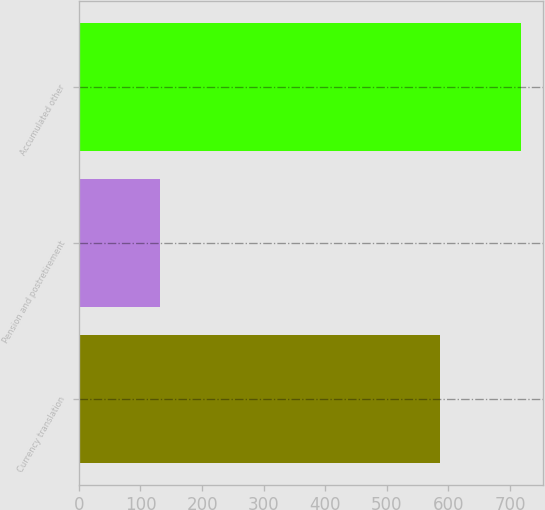<chart> <loc_0><loc_0><loc_500><loc_500><bar_chart><fcel>Currency translation<fcel>Pension and postretirement<fcel>Accumulated other<nl><fcel>587<fcel>131<fcel>718<nl></chart> 